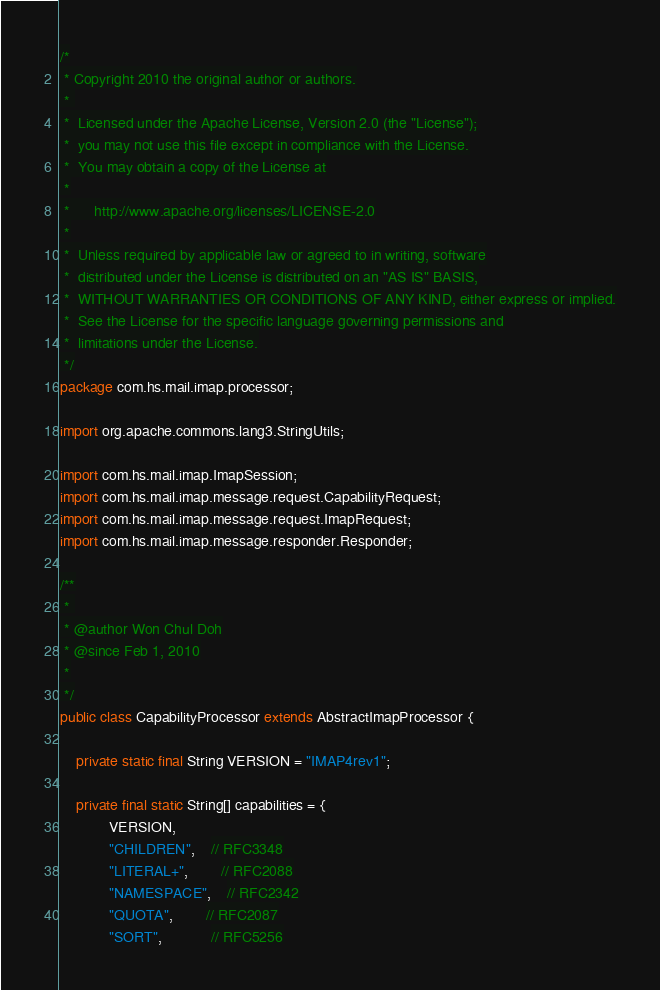<code> <loc_0><loc_0><loc_500><loc_500><_Java_>/*
 * Copyright 2010 the original author or authors.
 * 
 *  Licensed under the Apache License, Version 2.0 (the "License");
 *  you may not use this file except in compliance with the License.
 *  You may obtain a copy of the License at
 *
 *      http://www.apache.org/licenses/LICENSE-2.0
 *
 *  Unless required by applicable law or agreed to in writing, software
 *  distributed under the License is distributed on an "AS IS" BASIS,
 *  WITHOUT WARRANTIES OR CONDITIONS OF ANY KIND, either express or implied.
 *  See the License for the specific language governing permissions and
 *  limitations under the License.
 */
package com.hs.mail.imap.processor;

import org.apache.commons.lang3.StringUtils;

import com.hs.mail.imap.ImapSession;
import com.hs.mail.imap.message.request.CapabilityRequest;
import com.hs.mail.imap.message.request.ImapRequest;
import com.hs.mail.imap.message.responder.Responder;

/**
 * 
 * @author Won Chul Doh
 * @since Feb 1, 2010
 *
 */
public class CapabilityProcessor extends AbstractImapProcessor {
	
	private static final String VERSION = "IMAP4rev1";
	
	private final static String[] capabilities = { 
			VERSION,
			"CHILDREN", 	// RFC3348
			"LITERAL+",		// RFC2088
			"NAMESPACE",	// RFC2342
			"QUOTA", 		// RFC2087
			"SORT",			// RFC5256</code> 